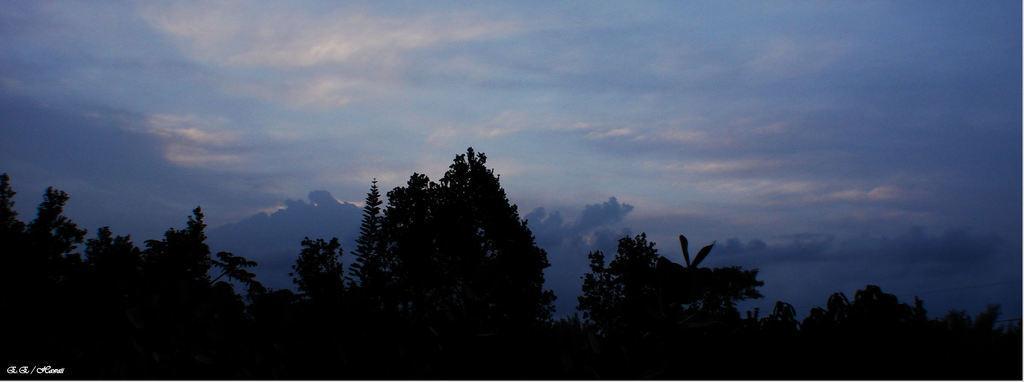Could you give a brief overview of what you see in this image? As we can see in the image there is a clear sky and below that there are trees. 